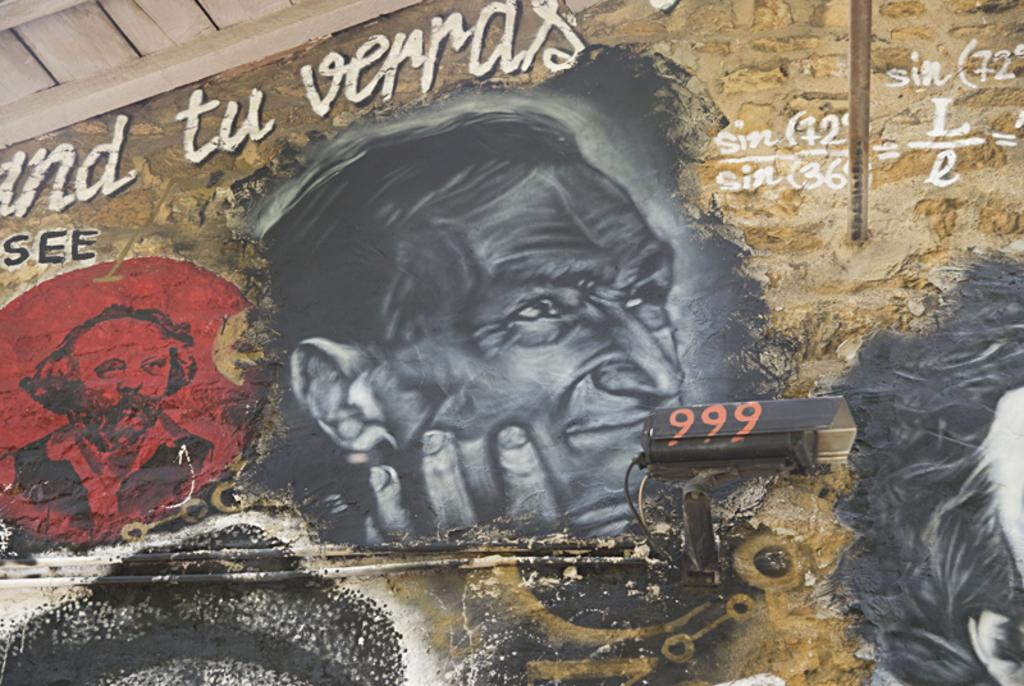What is present on the wall in the image? The wall has paintings on it and text. Can you describe the paintings on the wall? Unfortunately, the specific details of the paintings cannot be determined from the provided facts. What type of text is present on the wall? The type of text cannot be determined from the provided facts. What type of pipe can be seen in the image? There is no pipe present in the image. What smell is associated with the paintings on the wall? The image does not provide any information about smells, so it cannot be determined. 